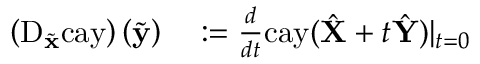Convert formula to latex. <formula><loc_0><loc_0><loc_500><loc_500>\begin{array} { r l } { \left ( D _ { \tilde { x } } c a y \right ) \left ( \tilde { y } \right ) } & \colon = \frac { d } { d t } c a y ( \hat { X } + t \hat { Y } ) | _ { t = 0 } } \end{array}</formula> 